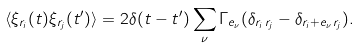Convert formula to latex. <formula><loc_0><loc_0><loc_500><loc_500>\langle \xi _ { { r } _ { i } } ( t ) \xi _ { { r } _ { j } } ( t ^ { \prime } ) \rangle = 2 \delta ( t - t ^ { \prime } ) \sum _ { \nu } \Gamma _ { e _ { \nu } } ( \delta _ { { r } _ { i } \, { r } _ { j } } - \delta _ { { r } _ { i } + { e } _ { \nu } \, { r } _ { j } } ) .</formula> 